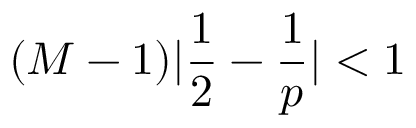<formula> <loc_0><loc_0><loc_500><loc_500>{ ( M - 1 ) | \frac { 1 } { 2 } - \frac { 1 } { p } | < 1 }</formula> 